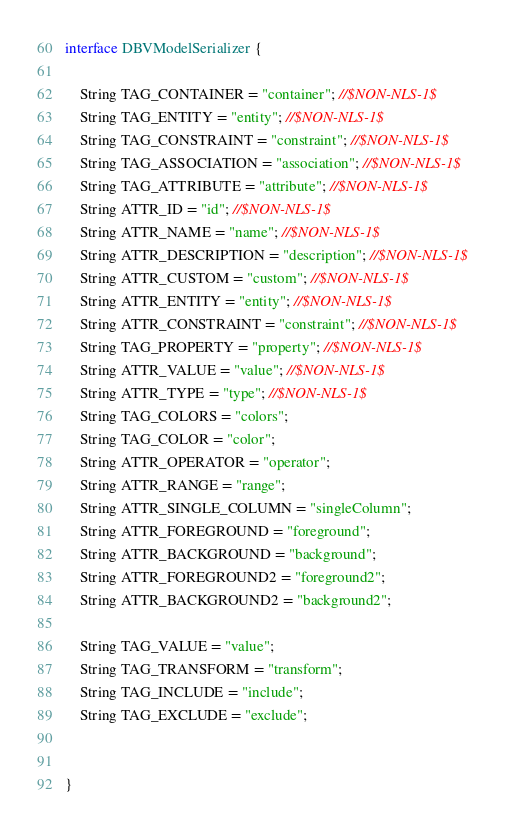<code> <loc_0><loc_0><loc_500><loc_500><_Java_>interface DBVModelSerializer {

    String TAG_CONTAINER = "container"; //$NON-NLS-1$
    String TAG_ENTITY = "entity"; //$NON-NLS-1$
    String TAG_CONSTRAINT = "constraint"; //$NON-NLS-1$
    String TAG_ASSOCIATION = "association"; //$NON-NLS-1$
    String TAG_ATTRIBUTE = "attribute"; //$NON-NLS-1$
    String ATTR_ID = "id"; //$NON-NLS-1$
    String ATTR_NAME = "name"; //$NON-NLS-1$
    String ATTR_DESCRIPTION = "description"; //$NON-NLS-1$
    String ATTR_CUSTOM = "custom"; //$NON-NLS-1$
    String ATTR_ENTITY = "entity"; //$NON-NLS-1$
    String ATTR_CONSTRAINT = "constraint"; //$NON-NLS-1$
    String TAG_PROPERTY = "property"; //$NON-NLS-1$
    String ATTR_VALUE = "value"; //$NON-NLS-1$
    String ATTR_TYPE = "type"; //$NON-NLS-1$
    String TAG_COLORS = "colors";
    String TAG_COLOR = "color";
    String ATTR_OPERATOR = "operator";
    String ATTR_RANGE = "range";
    String ATTR_SINGLE_COLUMN = "singleColumn";
    String ATTR_FOREGROUND = "foreground";
    String ATTR_BACKGROUND = "background";
    String ATTR_FOREGROUND2 = "foreground2";
    String ATTR_BACKGROUND2 = "background2";

    String TAG_VALUE = "value";
    String TAG_TRANSFORM = "transform";
    String TAG_INCLUDE = "include";
    String TAG_EXCLUDE = "exclude";


}
</code> 